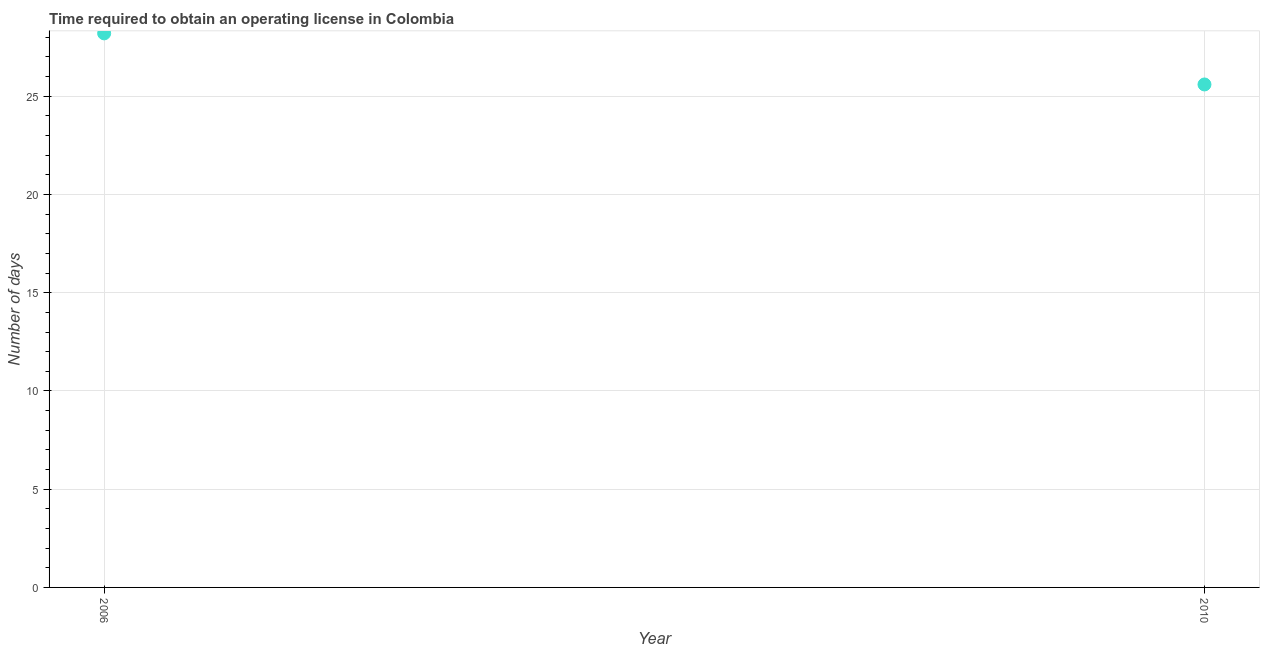What is the number of days to obtain operating license in 2006?
Your response must be concise. 28.2. Across all years, what is the maximum number of days to obtain operating license?
Your answer should be compact. 28.2. Across all years, what is the minimum number of days to obtain operating license?
Your answer should be very brief. 25.6. What is the sum of the number of days to obtain operating license?
Your response must be concise. 53.8. What is the difference between the number of days to obtain operating license in 2006 and 2010?
Provide a short and direct response. 2.6. What is the average number of days to obtain operating license per year?
Make the answer very short. 26.9. What is the median number of days to obtain operating license?
Your response must be concise. 26.9. In how many years, is the number of days to obtain operating license greater than 14 days?
Make the answer very short. 2. What is the ratio of the number of days to obtain operating license in 2006 to that in 2010?
Provide a short and direct response. 1.1. Is the number of days to obtain operating license in 2006 less than that in 2010?
Your answer should be compact. No. Does the number of days to obtain operating license monotonically increase over the years?
Your answer should be compact. No. How many dotlines are there?
Your answer should be compact. 1. Does the graph contain any zero values?
Your answer should be very brief. No. Does the graph contain grids?
Your response must be concise. Yes. What is the title of the graph?
Provide a succinct answer. Time required to obtain an operating license in Colombia. What is the label or title of the X-axis?
Provide a succinct answer. Year. What is the label or title of the Y-axis?
Offer a terse response. Number of days. What is the Number of days in 2006?
Provide a short and direct response. 28.2. What is the Number of days in 2010?
Keep it short and to the point. 25.6. What is the ratio of the Number of days in 2006 to that in 2010?
Keep it short and to the point. 1.1. 